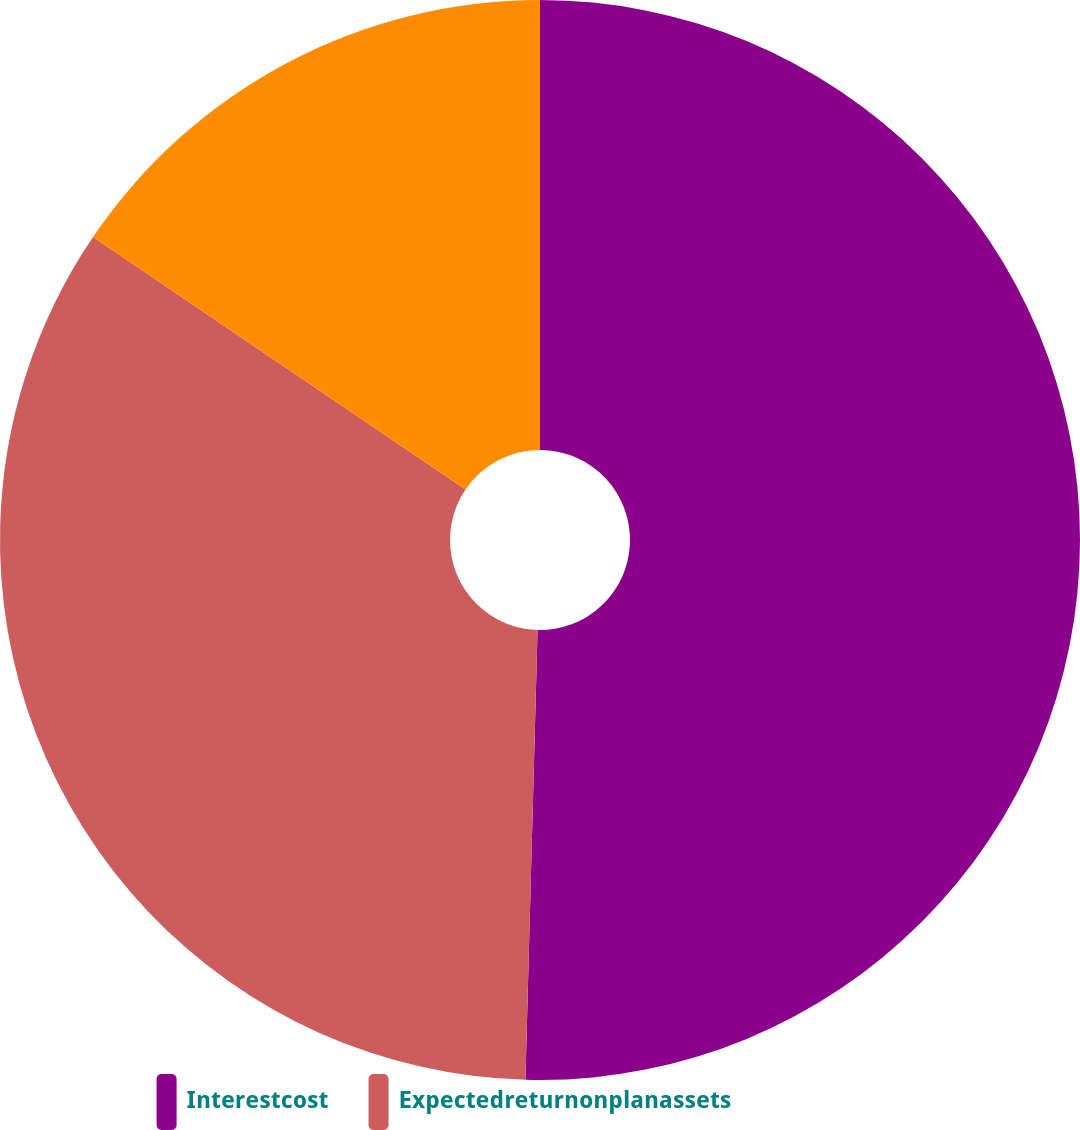<chart> <loc_0><loc_0><loc_500><loc_500><pie_chart><fcel>Interestcost<fcel>Expectedreturnonplanassets<fcel>Unnamed: 2<nl><fcel>50.43%<fcel>34.05%<fcel>15.52%<nl></chart> 